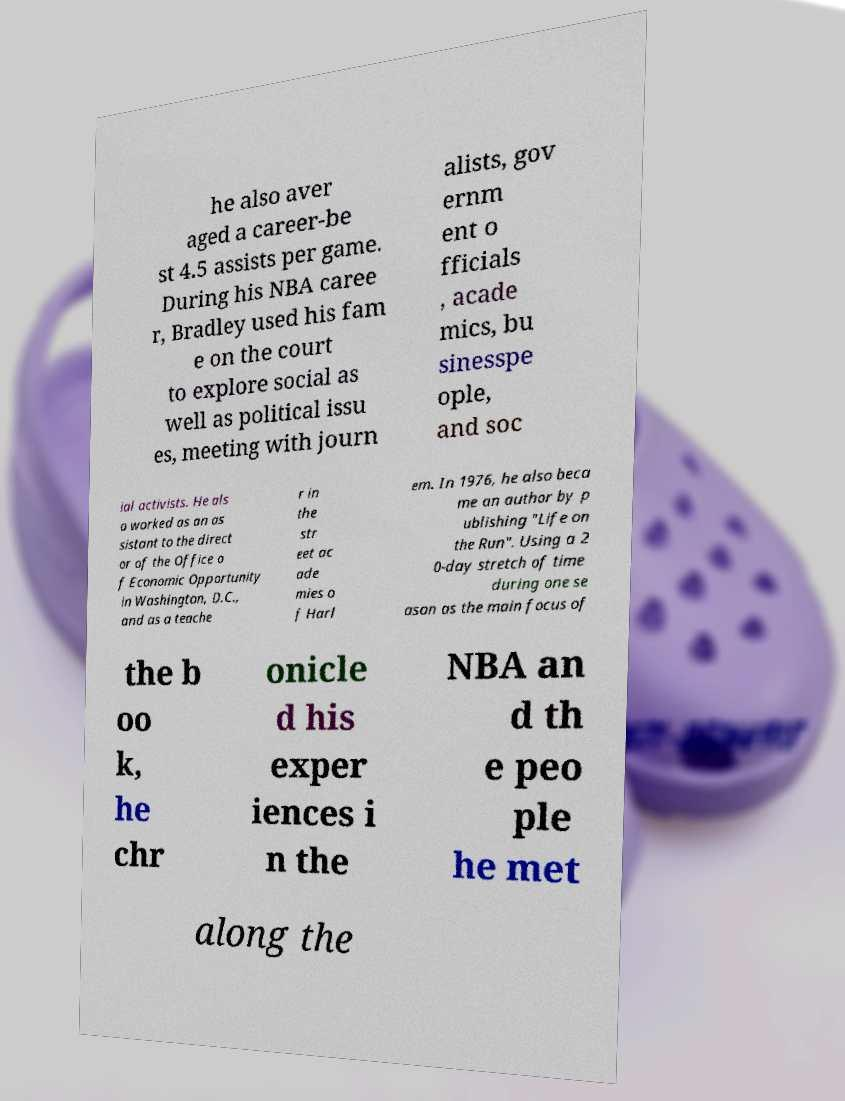I need the written content from this picture converted into text. Can you do that? he also aver aged a career-be st 4.5 assists per game. During his NBA caree r, Bradley used his fam e on the court to explore social as well as political issu es, meeting with journ alists, gov ernm ent o fficials , acade mics, bu sinesspe ople, and soc ial activists. He als o worked as an as sistant to the direct or of the Office o f Economic Opportunity in Washington, D.C., and as a teache r in the str eet ac ade mies o f Harl em. In 1976, he also beca me an author by p ublishing "Life on the Run". Using a 2 0-day stretch of time during one se ason as the main focus of the b oo k, he chr onicle d his exper iences i n the NBA an d th e peo ple he met along the 